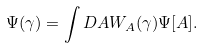<formula> <loc_0><loc_0><loc_500><loc_500>\Psi ( \gamma ) = \int D A W _ { A } ( \gamma ) \Psi [ A ] .</formula> 